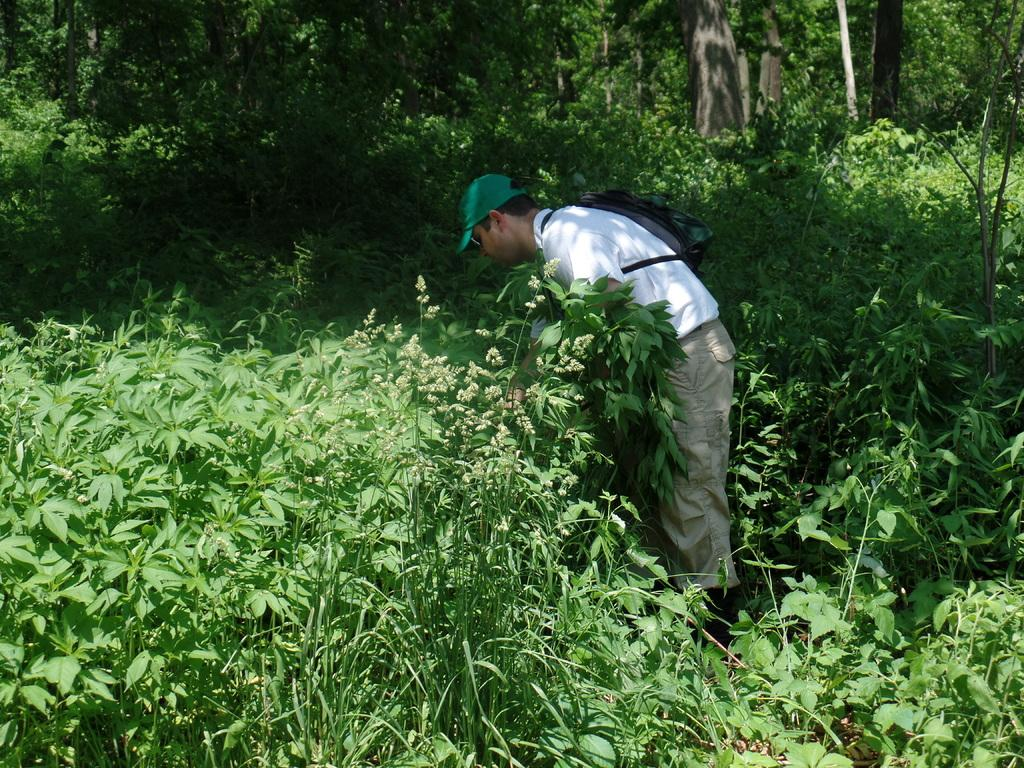What types of living organisms can be seen in the image? Plants can be seen in the image. Who is present in the image? There is a man in the image. What is the man carrying in the image? The man is carrying a bag. What can be seen in the background of the image? There are trees in the background of the image. What type of engine can be seen powering the apparatus in the image? There is no engine or apparatus present in the image; it features plants and a man carrying a bag. 